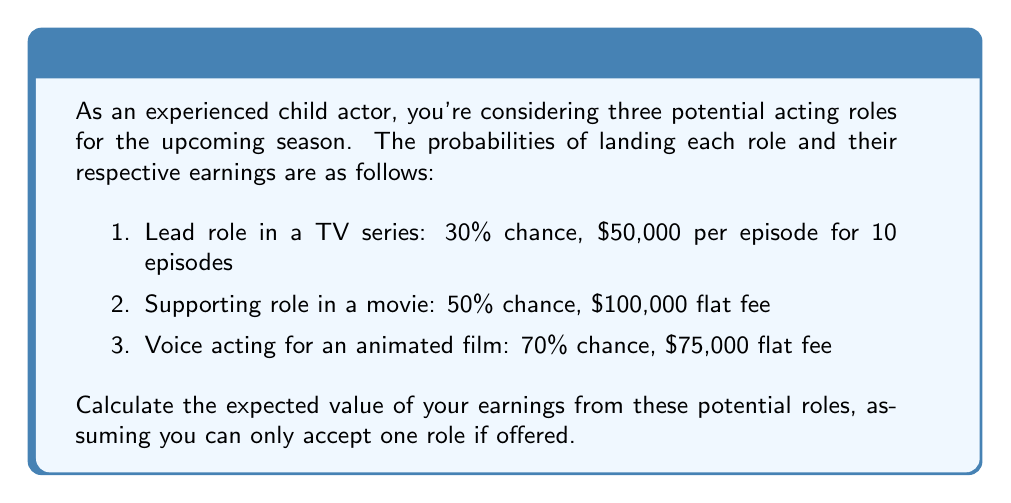Give your solution to this math problem. To calculate the expected value, we need to follow these steps:

1. Calculate the total earnings for each role:
   a. TV series: $50,000 × 10 = $500,000
   b. Movie: $100,000
   c. Voice acting: $75,000

2. Multiply each role's earnings by its probability:
   a. TV series: $500,000 × 0.30 = $150,000
   b. Movie: $100,000 × 0.50 = $50,000
   c. Voice acting: $75,000 × 0.70 = $52,500

3. Sum up the expected values:
   $$ E = 150,000 + 50,000 + 52,500 = 252,500 $$

Therefore, the expected value of earnings is $252,500.

However, since you can only accept one role if offered, we need to account for the mutually exclusive nature of these events. The probability of getting at least one role is:

$$ P(\text{at least one role}) = 1 - P(\text{no roles}) = 1 - (0.7 \times 0.5 \times 0.3) = 0.895 $$

Now, we need to calculate the conditional probabilities of each role, given that you get at least one:

$$ P(\text{TV}|\text{at least one}) = \frac{0.3}{0.895} \approx 0.3352 $$
$$ P(\text{Movie}|\text{at least one}) = \frac{0.5}{0.895} \approx 0.5587 $$
$$ P(\text{Voice}|\text{at least one}) = \frac{0.7}{0.895} \approx 0.7821 $$

The final expected value is:

$$ E = 500,000 \times 0.3352 + 100,000 \times 0.5587 + 75,000 \times 0.7821 = 280,670 $$
Answer: $280,670 